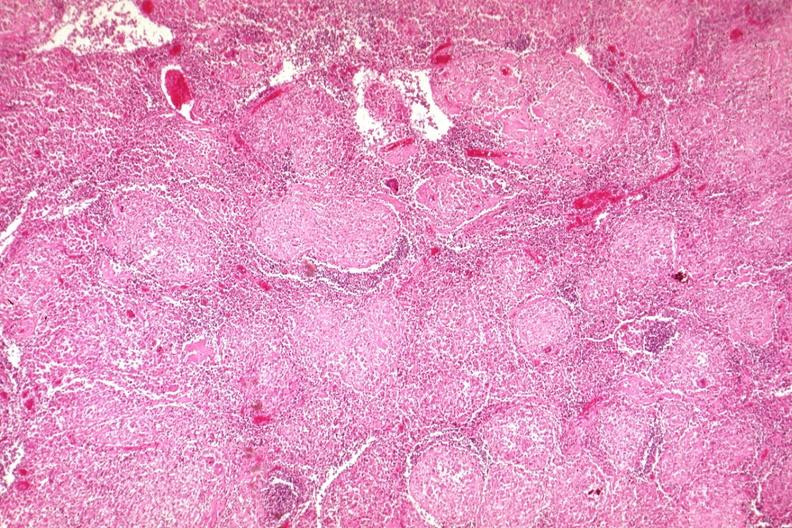what is present?
Answer the question using a single word or phrase. Sarcoidosis 